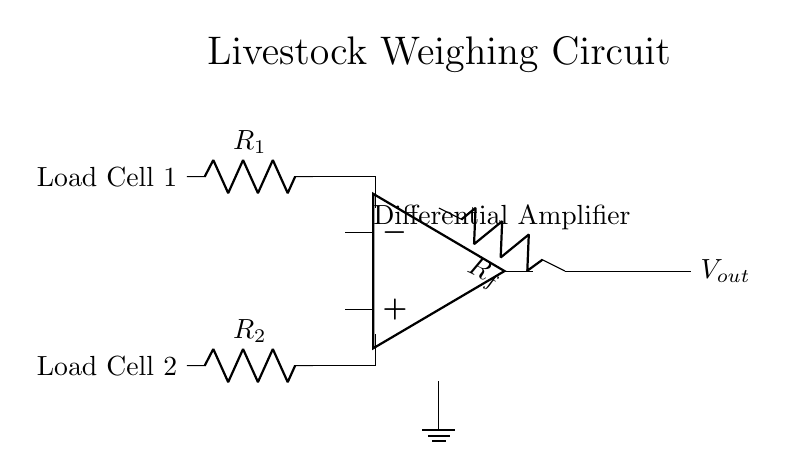What is the output voltage of the amplifier? The output voltage, denoted as Vout in the circuit diagram, is the voltage measured across the output terminals of the differential amplifier. The circuit does not specify a numerical value for Vout, so it would depend on the specific input from the load cells.
Answer: Vout What are the values of the resistors used in the circuit? The circuit diagram labels two resistors associated with the load cells as R1 and R2, and a feedback resistor labeled Rf, but it does not provide specific numerical values for these resistors. Their values would have to be determined from the circuit design or specifications.
Answer: R1, R2, Rf What is the function of the differential amplifier? The differential amplifier is designed to amplify the voltage difference between the two input signals coming from the load cells, which allows it to accurately weigh livestock by compensating for any potential imbalance or noise.
Answer: Amplification How do the load cells connect to the amplifier? Load Cell 1 and Load Cell 2 are connected as input signals to the differential amplifier, where the output of Load Cell 1 connects to the non-inverting input and the output of Load Cell 2 connects to the inverting input of the amplifier, enabling it to measure the difference in weight.
Answer: Inverting and non-inverting inputs What is the role of feedback resistor Rf? The feedback resistor Rf provides negative feedback to the amplifier, which stabilizes the gain of the amplifier and improves linearity, allowing for accurate measurements of the weight by controlling the output gain based on the input voltage difference.
Answer: Negative feedback stabilization 